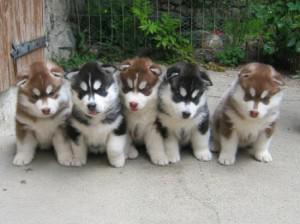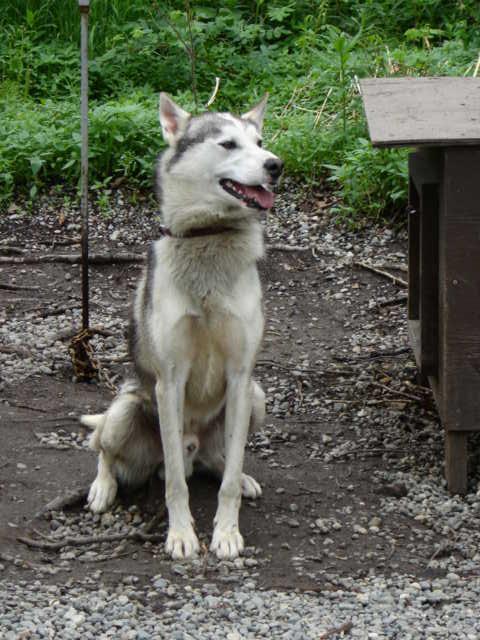The first image is the image on the left, the second image is the image on the right. Examine the images to the left and right. Is the description "The left image contains five forward-facing husky puppies in two different coat color combinations." accurate? Answer yes or no. Yes. The first image is the image on the left, the second image is the image on the right. Given the left and right images, does the statement "The left and right image contains a total of six dogs." hold true? Answer yes or no. Yes. 